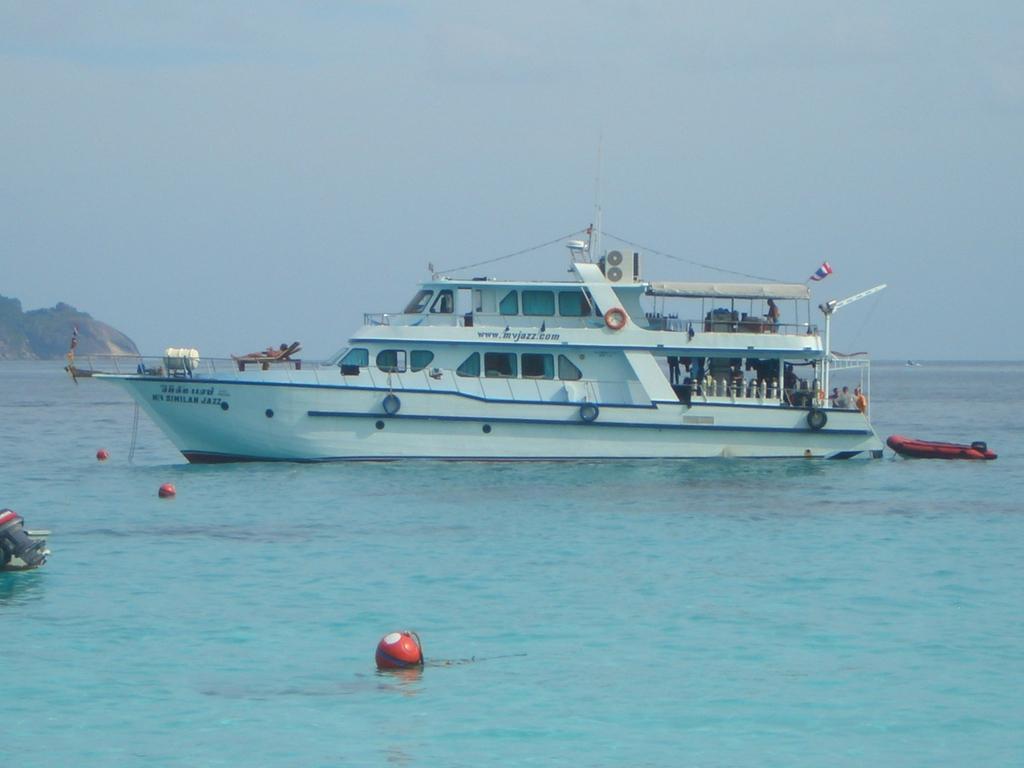Can you describe this image briefly? In the center of the image there is a ship sailing on the sea. On the left side of the image there is a rock hill. In the background there is a sky. 